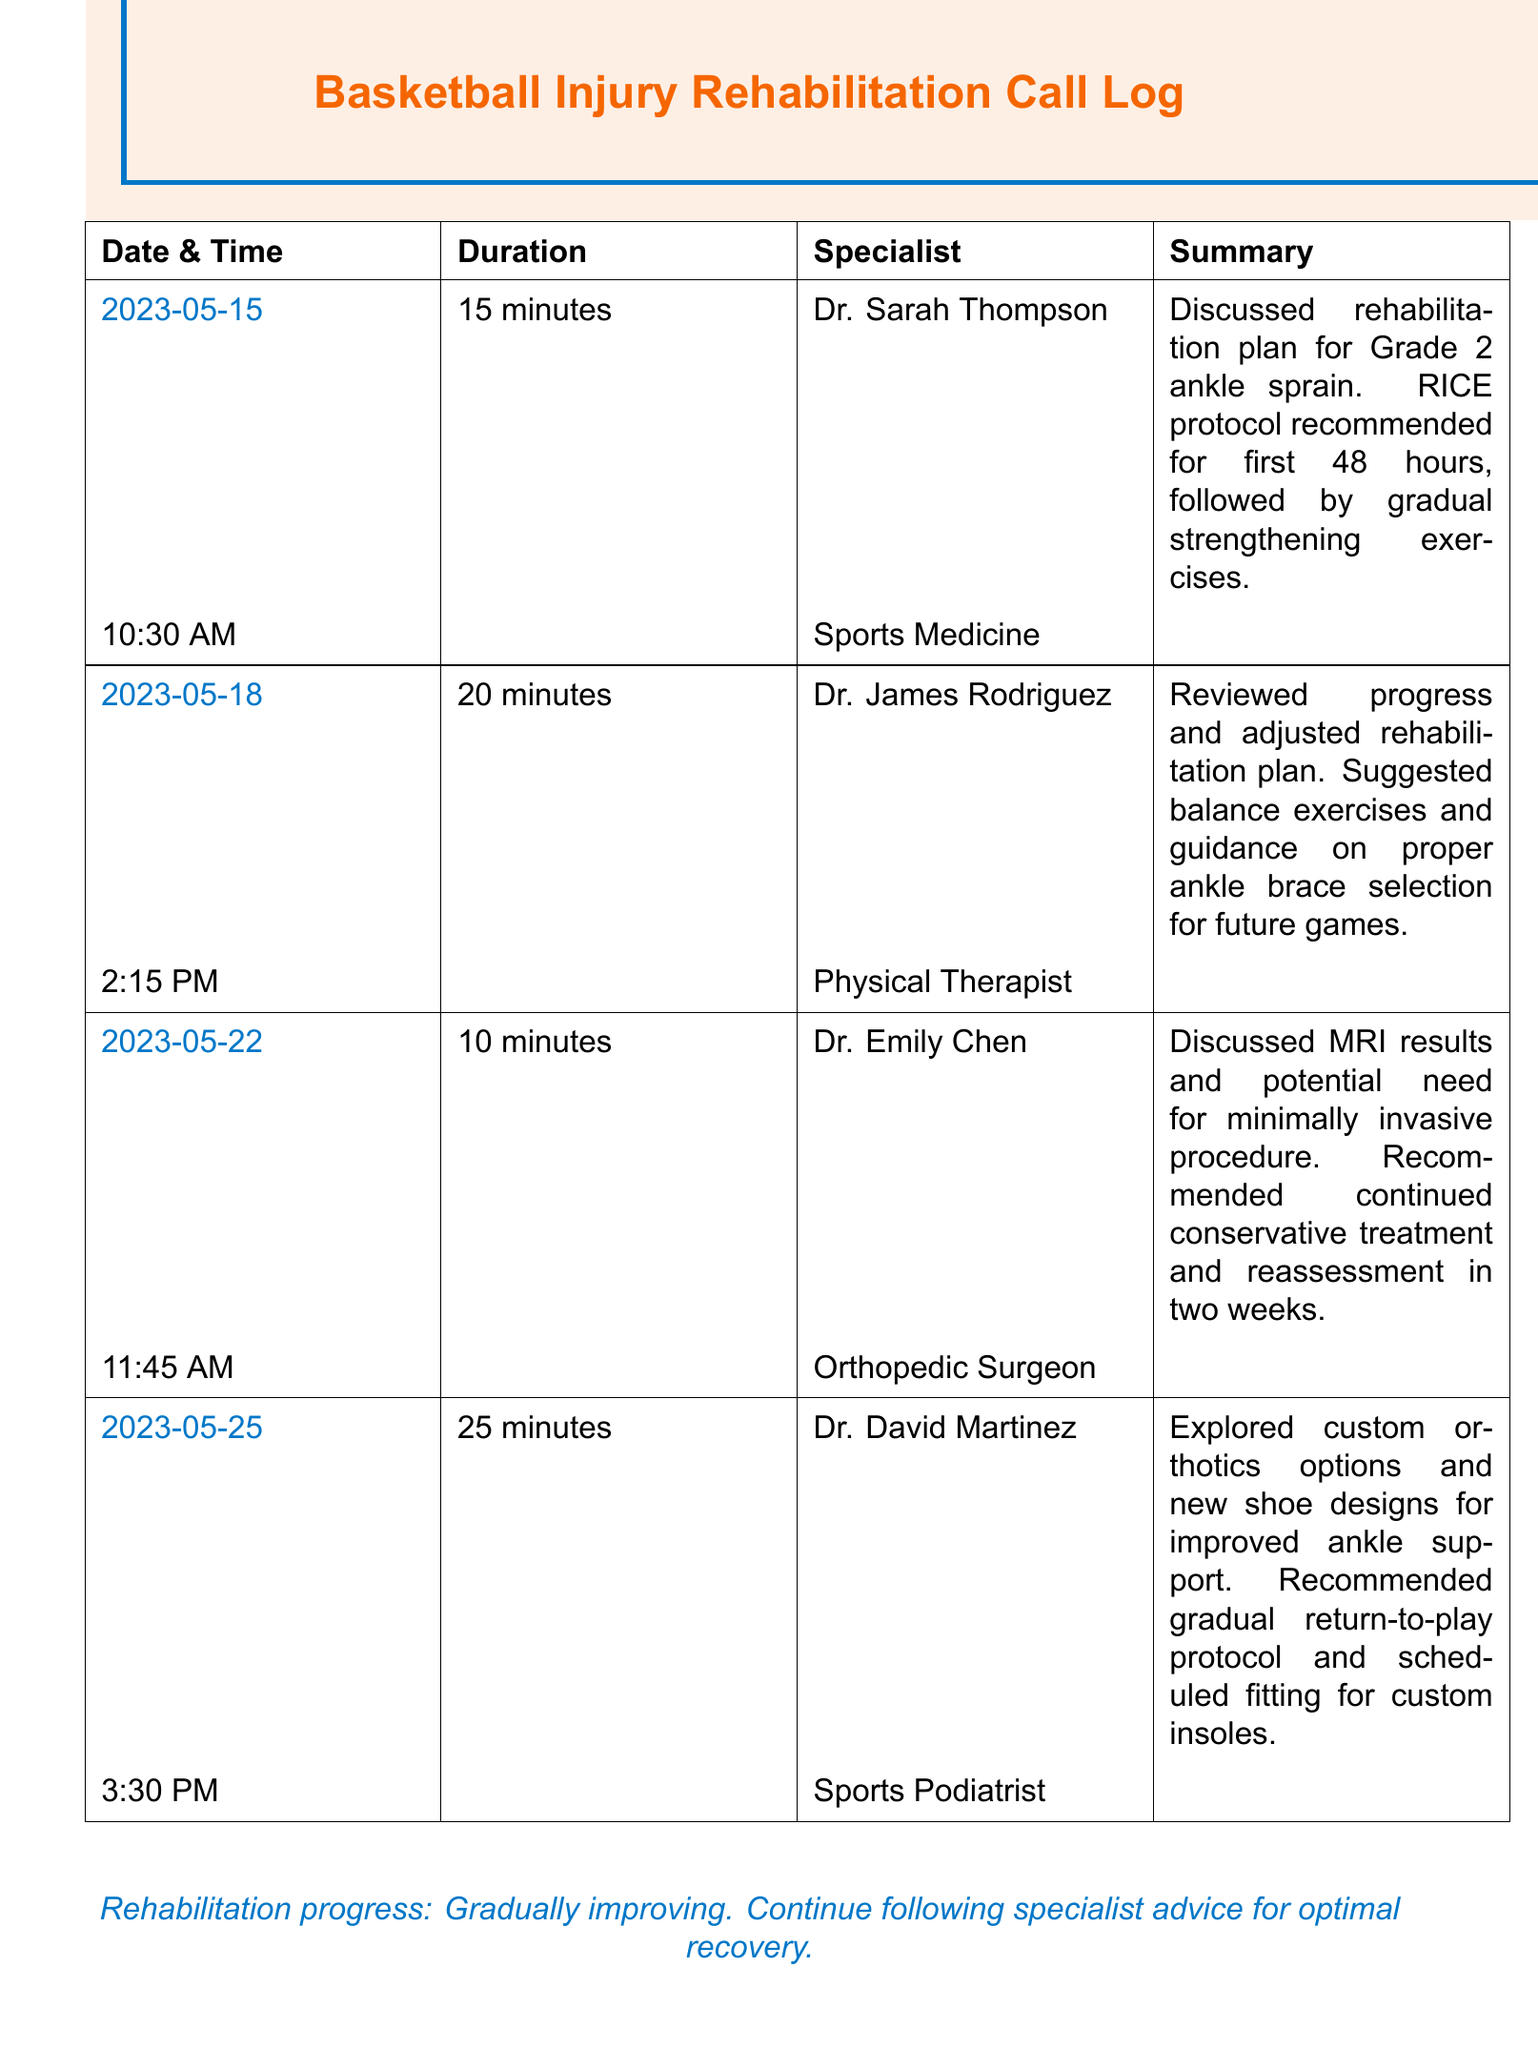What is the date of the first call? The first call is recorded on May 15, 2023.
Answer: May 15, 2023 Who is the specialist that discussed the MRI results? The specialist who discussed the MRI results is Dr. Emily Chen.
Answer: Dr. Emily Chen What is the recommended protocol for the first 48 hours? The recommended protocol for the first 48 hours is RICE.
Answer: RICE How long was the discussion with Dr. David Martinez? The discussion with Dr. David Martinez lasted 25 minutes.
Answer: 25 minutes What type of exercises were suggested during the rehabilitation plan? Balance exercises were suggested during the rehabilitation plan.
Answer: Balance exercises How many calls were made regarding the ankle injury? A total of four calls were made regarding the ankle injury.
Answer: Four calls What was discussed in the call with Dr. James Rodriguez? Dr. James Rodriguez reviewed progress and adjusted the rehabilitation plan.
Answer: Reviewed progress and adjusted the rehabilitation plan What is the last specialist consulted according to the log? The last specialist consulted in the log is Dr. David Martinez.
Answer: Dr. David Martinez 